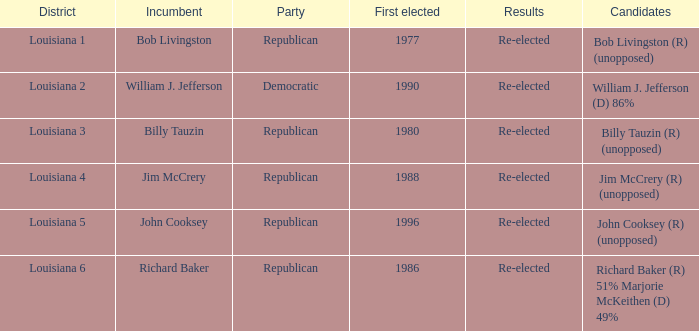What region does john cooksey represent? Louisiana 5. 